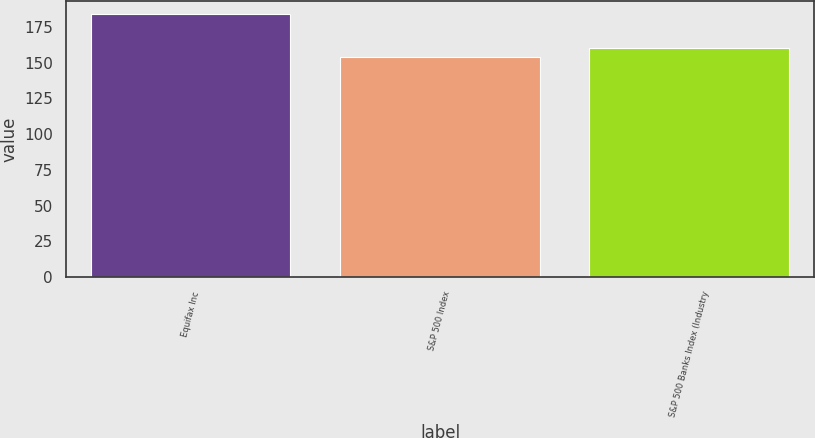Convert chart. <chart><loc_0><loc_0><loc_500><loc_500><bar_chart><fcel>Equifax Inc<fcel>S&P 500 Index<fcel>S&P 500 Banks Index (Industry<nl><fcel>183.8<fcel>153.57<fcel>160.27<nl></chart> 